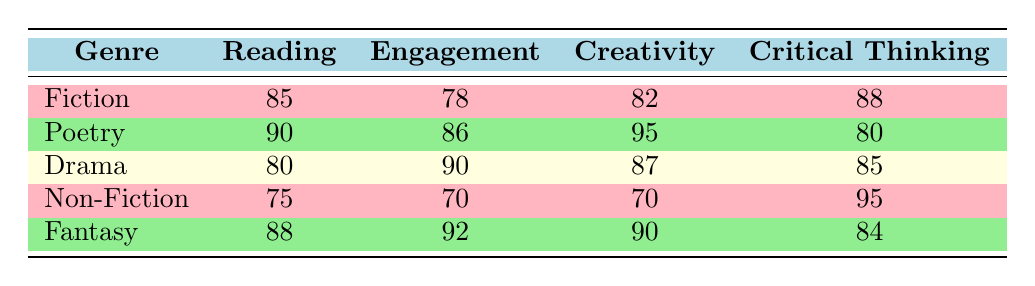What is the average reading score for Poetry? The table indicates that the average reading score for Poetry is listed as 90.
Answer: 90 Which genre has the highest average engagement level? According to the table, the genre with the highest average engagement level is Drama, with a score of 90.
Answer: Drama Is the average creativity score for Fiction greater than that of Non-Fiction? The average creativity score for Fiction is 82 while for Non-Fiction it is 70; thus, Fiction's score is greater.
Answer: Yes What is the difference in the average critical thinking score between Non-Fiction and Poetry? Non-Fiction has an average critical thinking score of 95, while Poetry's score is 80. The difference is 95 - 80 = 15.
Answer: 15 What is the average reading score across all genres? To find the average, add the reading scores (85, 90, 80, 75, 88) which totals 418 and divide by 5. Thus, the average reading score is 418 / 5 = 83.6.
Answer: 83.6 Does Fantasy have a higher average creativity score compared to Drama? Fantasy's average creativity score is 90, while Drama's is 87, indicating that Fantasy is higher.
Answer: Yes Which genre shows the lowest engagement level? From the table, Non-Fiction has the lowest engagement level at 70.
Answer: Non-Fiction What are the average scores in critical thinking for genres with an engagement level above 80? The genres with an engagement level above 80 are Poetry (80), Drama (85), and Fantasy (84). Their critical thinking scores are 80, 85, and 84 respectively. The average of these is (80 + 85 + 84) / 3 = 83.
Answer: 83 What is the total of average reading, engagement, creativity, and critical thinking scores for Fiction? For Fiction, the average scores are 85 (reading) + 78 (engagement) + 82 (creativity) + 88 (critical thinking). Summing these gives 85 + 78 + 82 + 88 = 333.
Answer: 333 